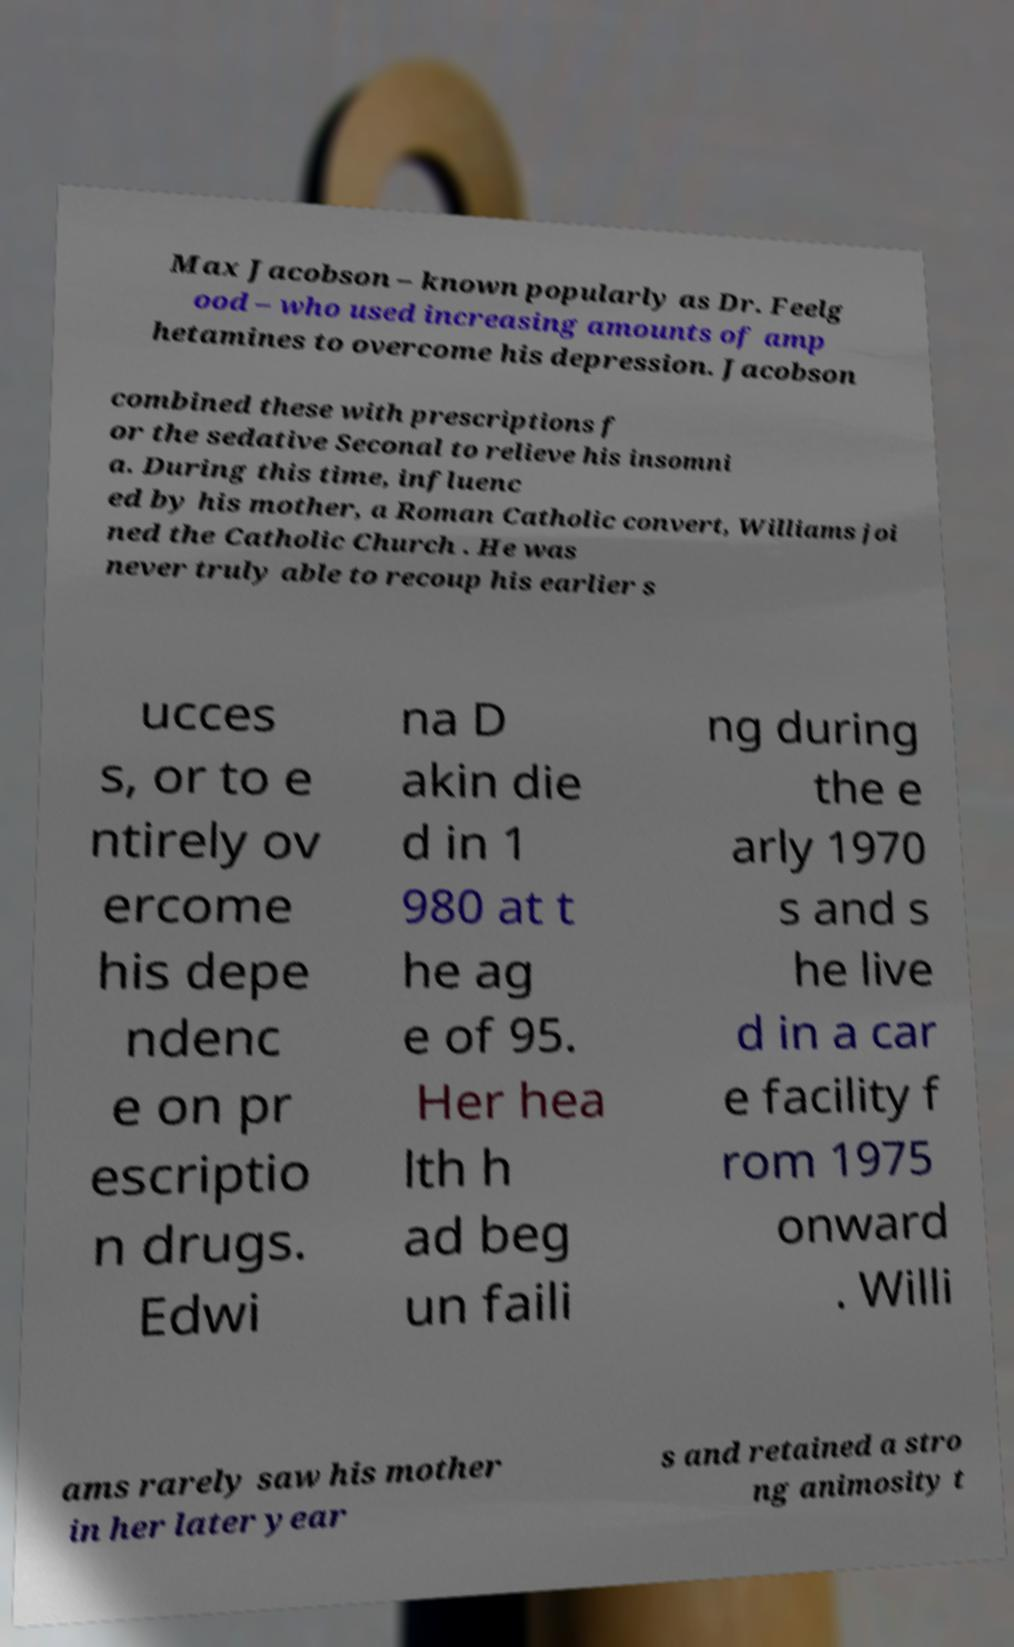Could you assist in decoding the text presented in this image and type it out clearly? Max Jacobson – known popularly as Dr. Feelg ood – who used increasing amounts of amp hetamines to overcome his depression. Jacobson combined these with prescriptions f or the sedative Seconal to relieve his insomni a. During this time, influenc ed by his mother, a Roman Catholic convert, Williams joi ned the Catholic Church . He was never truly able to recoup his earlier s ucces s, or to e ntirely ov ercome his depe ndenc e on pr escriptio n drugs. Edwi na D akin die d in 1 980 at t he ag e of 95. Her hea lth h ad beg un faili ng during the e arly 1970 s and s he live d in a car e facility f rom 1975 onward . Willi ams rarely saw his mother in her later year s and retained a stro ng animosity t 